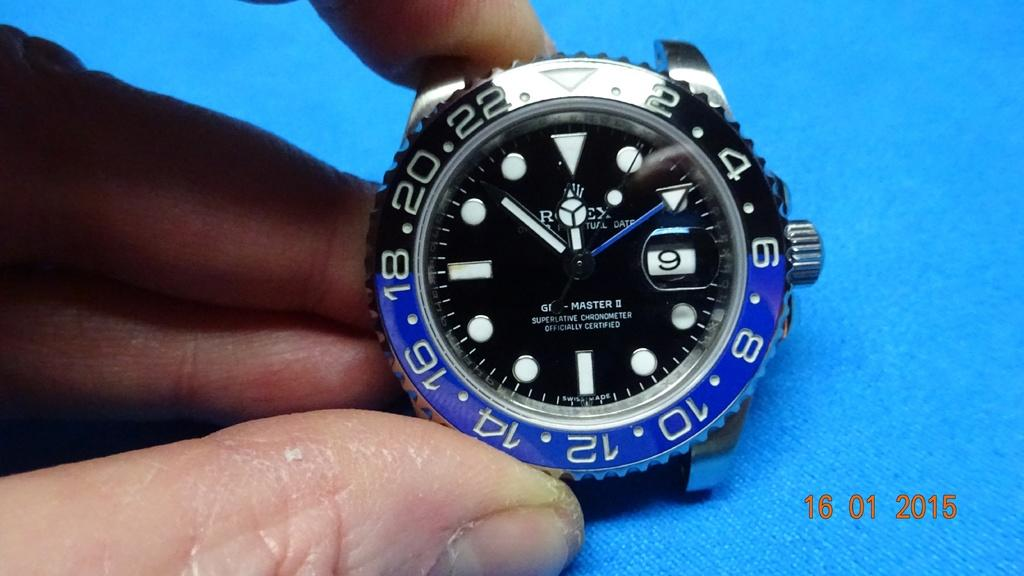<image>
Render a clear and concise summary of the photo. Person holding a face of a watch which says Rolex on it. 